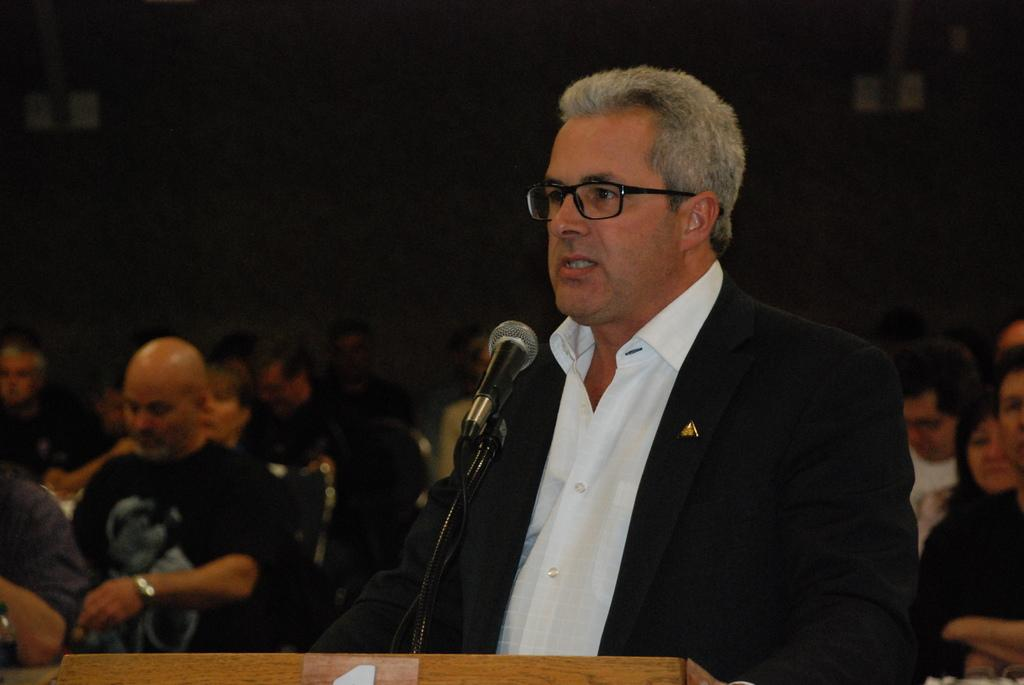What is the person near in the image? The person is standing near a podium in the image. What can be seen in the background of the image? There are people sitting in chairs in the background of the image. What type of guitar is the person playing in the image? There is no guitar present in the image; the person is standing near a podium. 